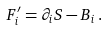<formula> <loc_0><loc_0><loc_500><loc_500>F ^ { \prime } _ { i } = \partial _ { i } S - B _ { i } \, .</formula> 